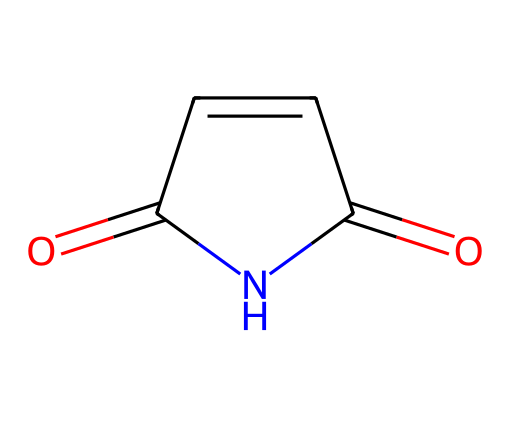What is the name of this chemical? The SMILES representation O=C1C=CC(=O)N1 corresponds to a cyclic structure with a nitrogen atom and two carbonyl (C=O) groups, which defines it as maleimide.
Answer: maleimide How many carbon atoms are present in this structure? By analyzing the structure, we can see that there are four carbon atoms connected within the ring and from the C=O groups.
Answer: four Is this compound an imide? The presence of the nitrogen atom bonded to two carbonyl groups confirms that this is indeed an imide compound.
Answer: yes What is the type of bonding between the carbon and oxygen in the carbonyl groups? The two carbonyl groups indicate double bonding between the carbon and oxygen atoms, characteristic of carbonyl functional groups.
Answer: double How many rings are present in this chemical structure? The cyclic structure illustrated in the SMILES shows that there is one ring present as it encircles the nitrogen with carbon atoms.
Answer: one What functional groups can be identified in maleimide? The compound features carbonyl groups (C=O) and an imide functional group, which is specific to maleimide's chemical structure.
Answer: carbonyl and imide What is the significance of the nitrogen atom in imides? The nitrogen atom is crucial as it defines the imide structure, influencing reactivity and properties like thermal stability and solubility.
Answer: reactivity and stability 